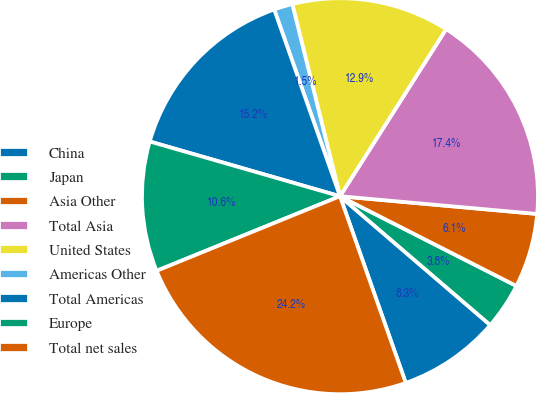Convert chart. <chart><loc_0><loc_0><loc_500><loc_500><pie_chart><fcel>China<fcel>Japan<fcel>Asia Other<fcel>Total Asia<fcel>United States<fcel>Americas Other<fcel>Total Americas<fcel>Europe<fcel>Total net sales<nl><fcel>8.33%<fcel>3.79%<fcel>6.06%<fcel>17.42%<fcel>12.88%<fcel>1.52%<fcel>15.15%<fcel>10.61%<fcel>24.24%<nl></chart> 